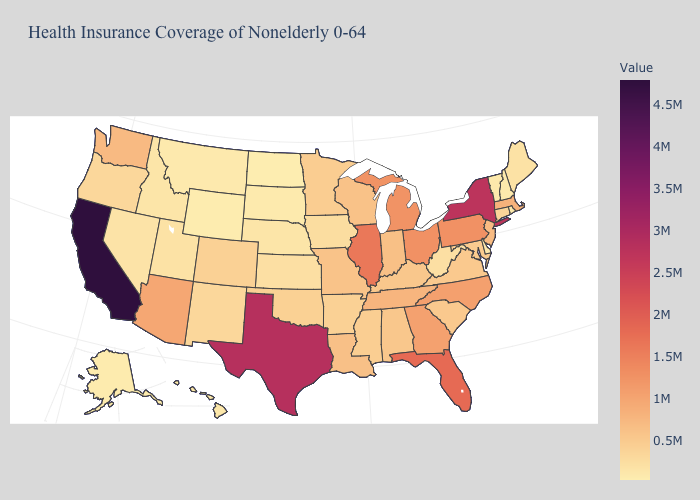Which states have the highest value in the USA?
Write a very short answer. California. Does Wyoming have the lowest value in the West?
Write a very short answer. Yes. Which states have the highest value in the USA?
Concise answer only. California. Which states have the highest value in the USA?
Be succinct. California. Does California have the highest value in the USA?
Give a very brief answer. Yes. Which states have the lowest value in the USA?
Short answer required. North Dakota. 